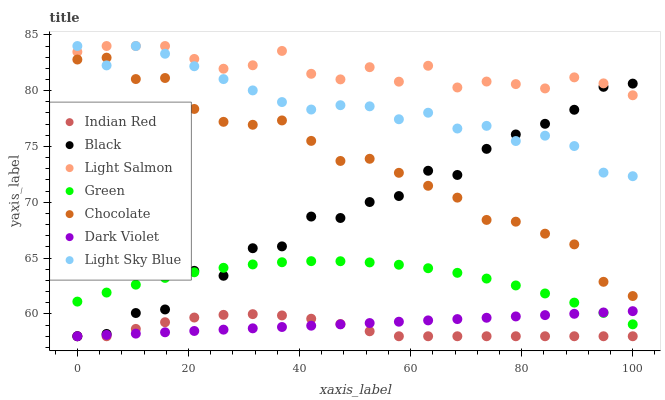Does Indian Red have the minimum area under the curve?
Answer yes or no. Yes. Does Light Salmon have the maximum area under the curve?
Answer yes or no. Yes. Does Dark Violet have the minimum area under the curve?
Answer yes or no. No. Does Dark Violet have the maximum area under the curve?
Answer yes or no. No. Is Dark Violet the smoothest?
Answer yes or no. Yes. Is Black the roughest?
Answer yes or no. Yes. Is Chocolate the smoothest?
Answer yes or no. No. Is Chocolate the roughest?
Answer yes or no. No. Does Dark Violet have the lowest value?
Answer yes or no. Yes. Does Chocolate have the lowest value?
Answer yes or no. No. Does Light Sky Blue have the highest value?
Answer yes or no. Yes. Does Dark Violet have the highest value?
Answer yes or no. No. Is Green less than Light Sky Blue?
Answer yes or no. Yes. Is Light Salmon greater than Green?
Answer yes or no. Yes. Does Light Salmon intersect Light Sky Blue?
Answer yes or no. Yes. Is Light Salmon less than Light Sky Blue?
Answer yes or no. No. Is Light Salmon greater than Light Sky Blue?
Answer yes or no. No. Does Green intersect Light Sky Blue?
Answer yes or no. No. 